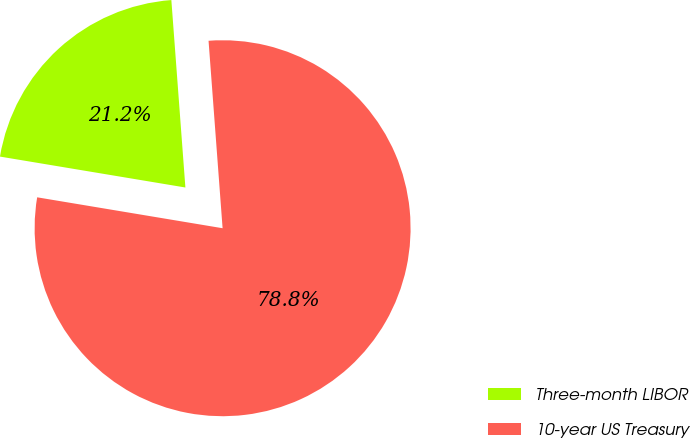<chart> <loc_0><loc_0><loc_500><loc_500><pie_chart><fcel>Three-month LIBOR<fcel>10-year US Treasury<nl><fcel>21.18%<fcel>78.82%<nl></chart> 